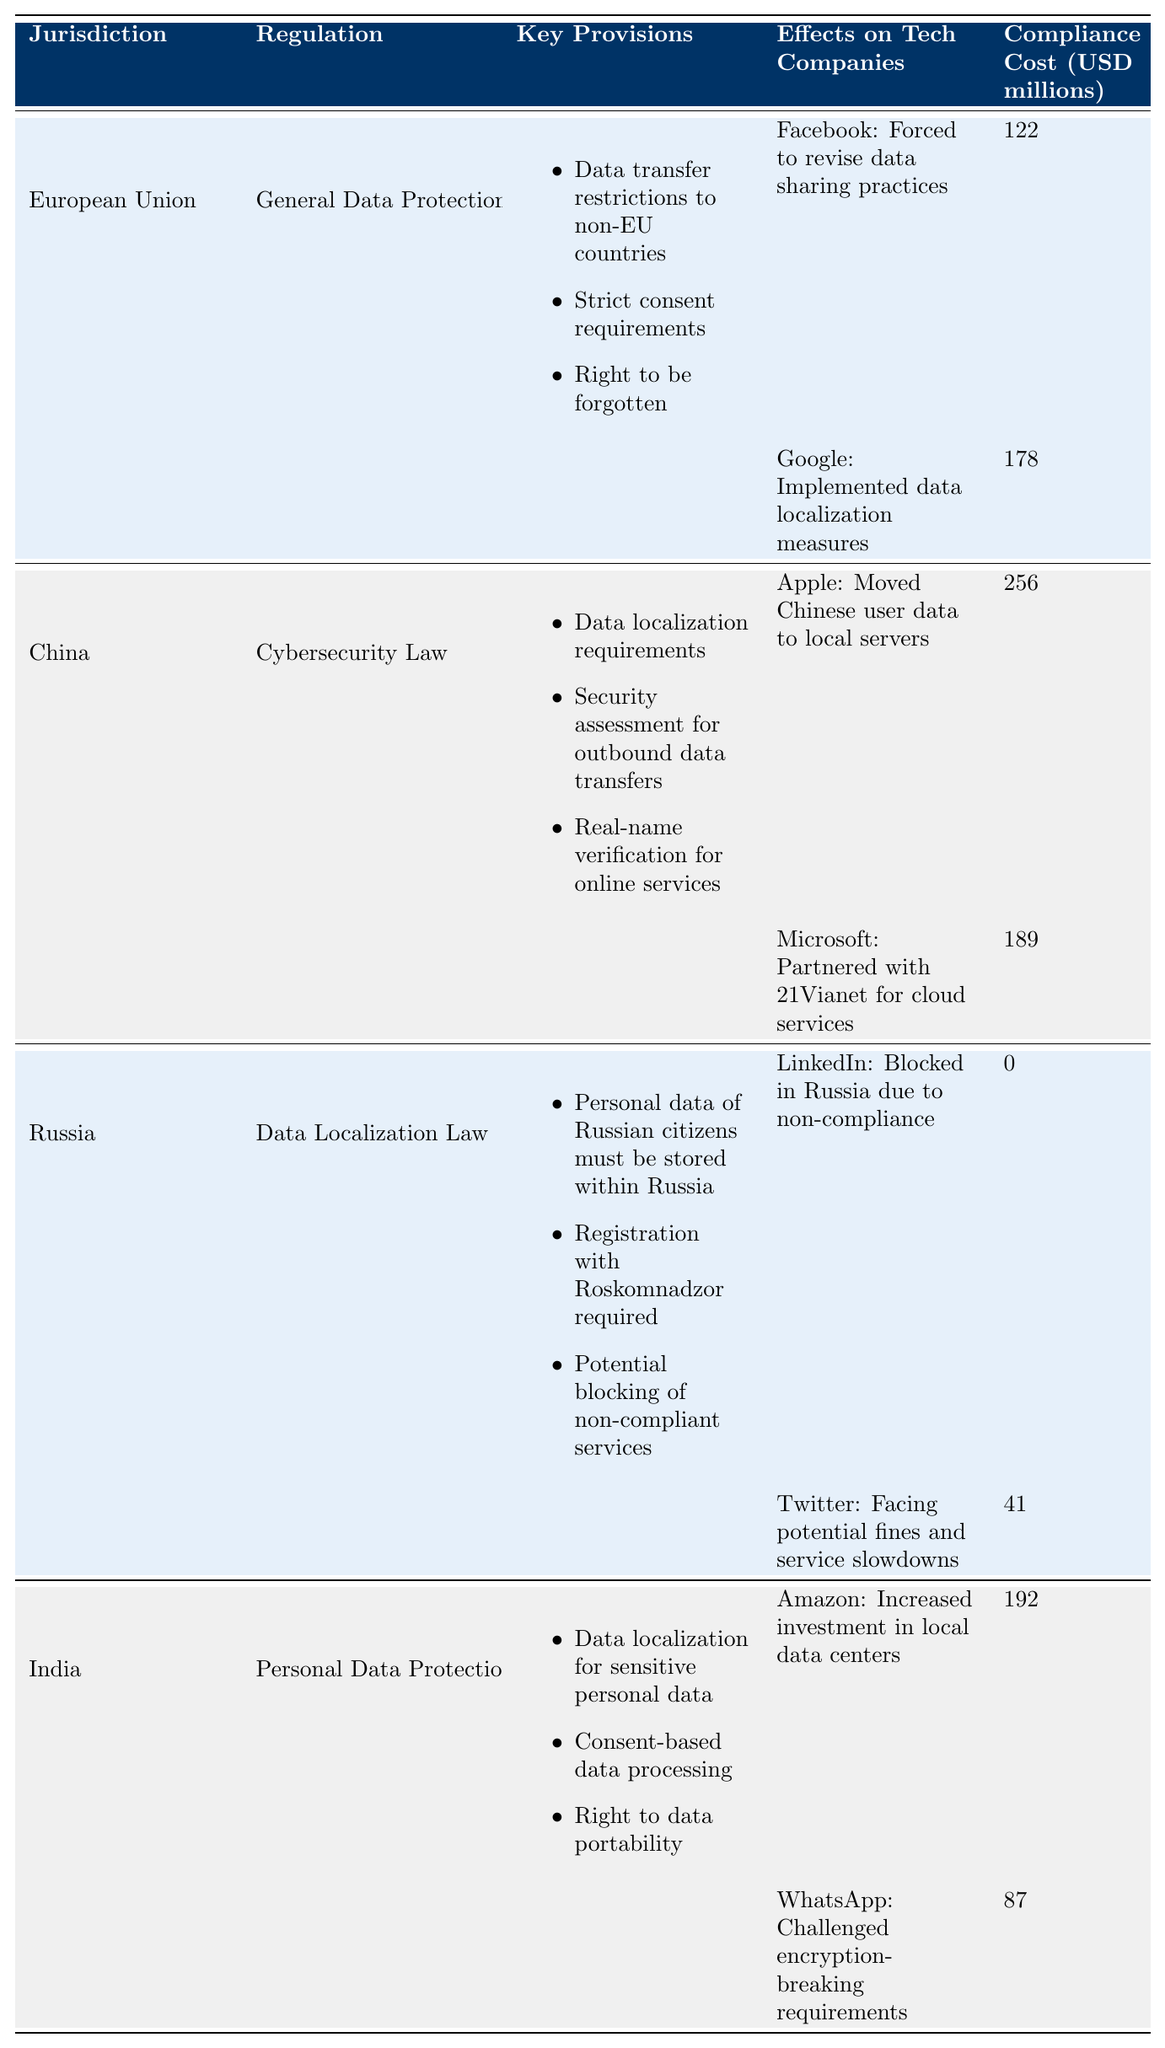What is the compliance cost for Google under GDPR? The table lists Google's compliance cost under GDPR as 178 million USD.
Answer: 178 million USD Which jurisdiction has the highest compliance cost for tech companies? By comparing the compliance costs, China's Cybersecurity Law has the highest cost of 256 million USD for Apple.
Answer: China How many tech companies are affected by the Data Localization Law in Russia? The table shows that two companies, LinkedIn and Twitter, are affected by Russia's Data Localization Law.
Answer: Two companies What is the total compliance cost for tech companies in the European Union? The compliance costs for Facebook and Google under GDPR are 122 million and 178 million USD, respectively. Summing these gives 122 + 178 = 300 million USD.
Answer: 300 million USD Did LinkedIn incur any compliance costs associated with the Data Localization Law in Russia? The table indicates that LinkedIn was blocked in Russia due to non-compliance and incurred a compliance cost of 0 million USD.
Answer: Yes, 0 million USD What is the impact of Apple's compliance with China's Cybersecurity Law? The table states that Apple moved Chinese user data to local servers as a response to the Cybersecurity Law.
Answer: Moved data to local servers Which regulation has the most stringent requirements in terms of data consent among the listed jurisdictions? The GDPR in the European Union includes strict consent requirements, making it the most stringent among the listed regulations.
Answer: GDPR What is the average compliance cost for the tech companies impacted by the Personal Data Protection Bill in India? The compliance costs for Amazon and WhatsApp are 192 million and 87 million USD, respectively. To find the average: (192 + 87) / 2 = 139.5 million USD.
Answer: 139.5 million USD Does the compliance cost for Twitter in Russia indicate a profit loss? The compliance cost is listed as 41 million USD; a question regarding profit loss would require more financial context outside this table. Thus, we cannot determine profit loss from this data alone.
Answer: No Which company had to implement data localization measures and what were the associated costs? Google was reported to have implemented data localization measures under GDPR, costing 178 million USD.
Answer: Google, 178 million USD 